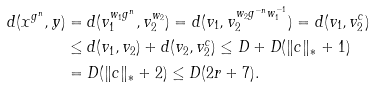Convert formula to latex. <formula><loc_0><loc_0><loc_500><loc_500>d ( x ^ { g ^ { n } } , y ) & = d ( v _ { 1 } ^ { w _ { 1 } g ^ { n } } , v _ { 2 } ^ { w _ { 2 } } ) = d ( v _ { 1 } , v _ { 2 } ^ { w _ { 2 } g ^ { - n } w _ { 1 } ^ { - 1 } } ) = d ( v _ { 1 } , v _ { 2 } ^ { c } ) \\ & \leq d ( v _ { 1 } , v _ { 2 } ) + d ( v _ { 2 } , v _ { 2 } ^ { c } ) \leq D + D ( \| c \| _ { * } + 1 ) \\ & = D ( \| c \| _ { * } + 2 ) \leq D ( 2 r + 7 ) .</formula> 